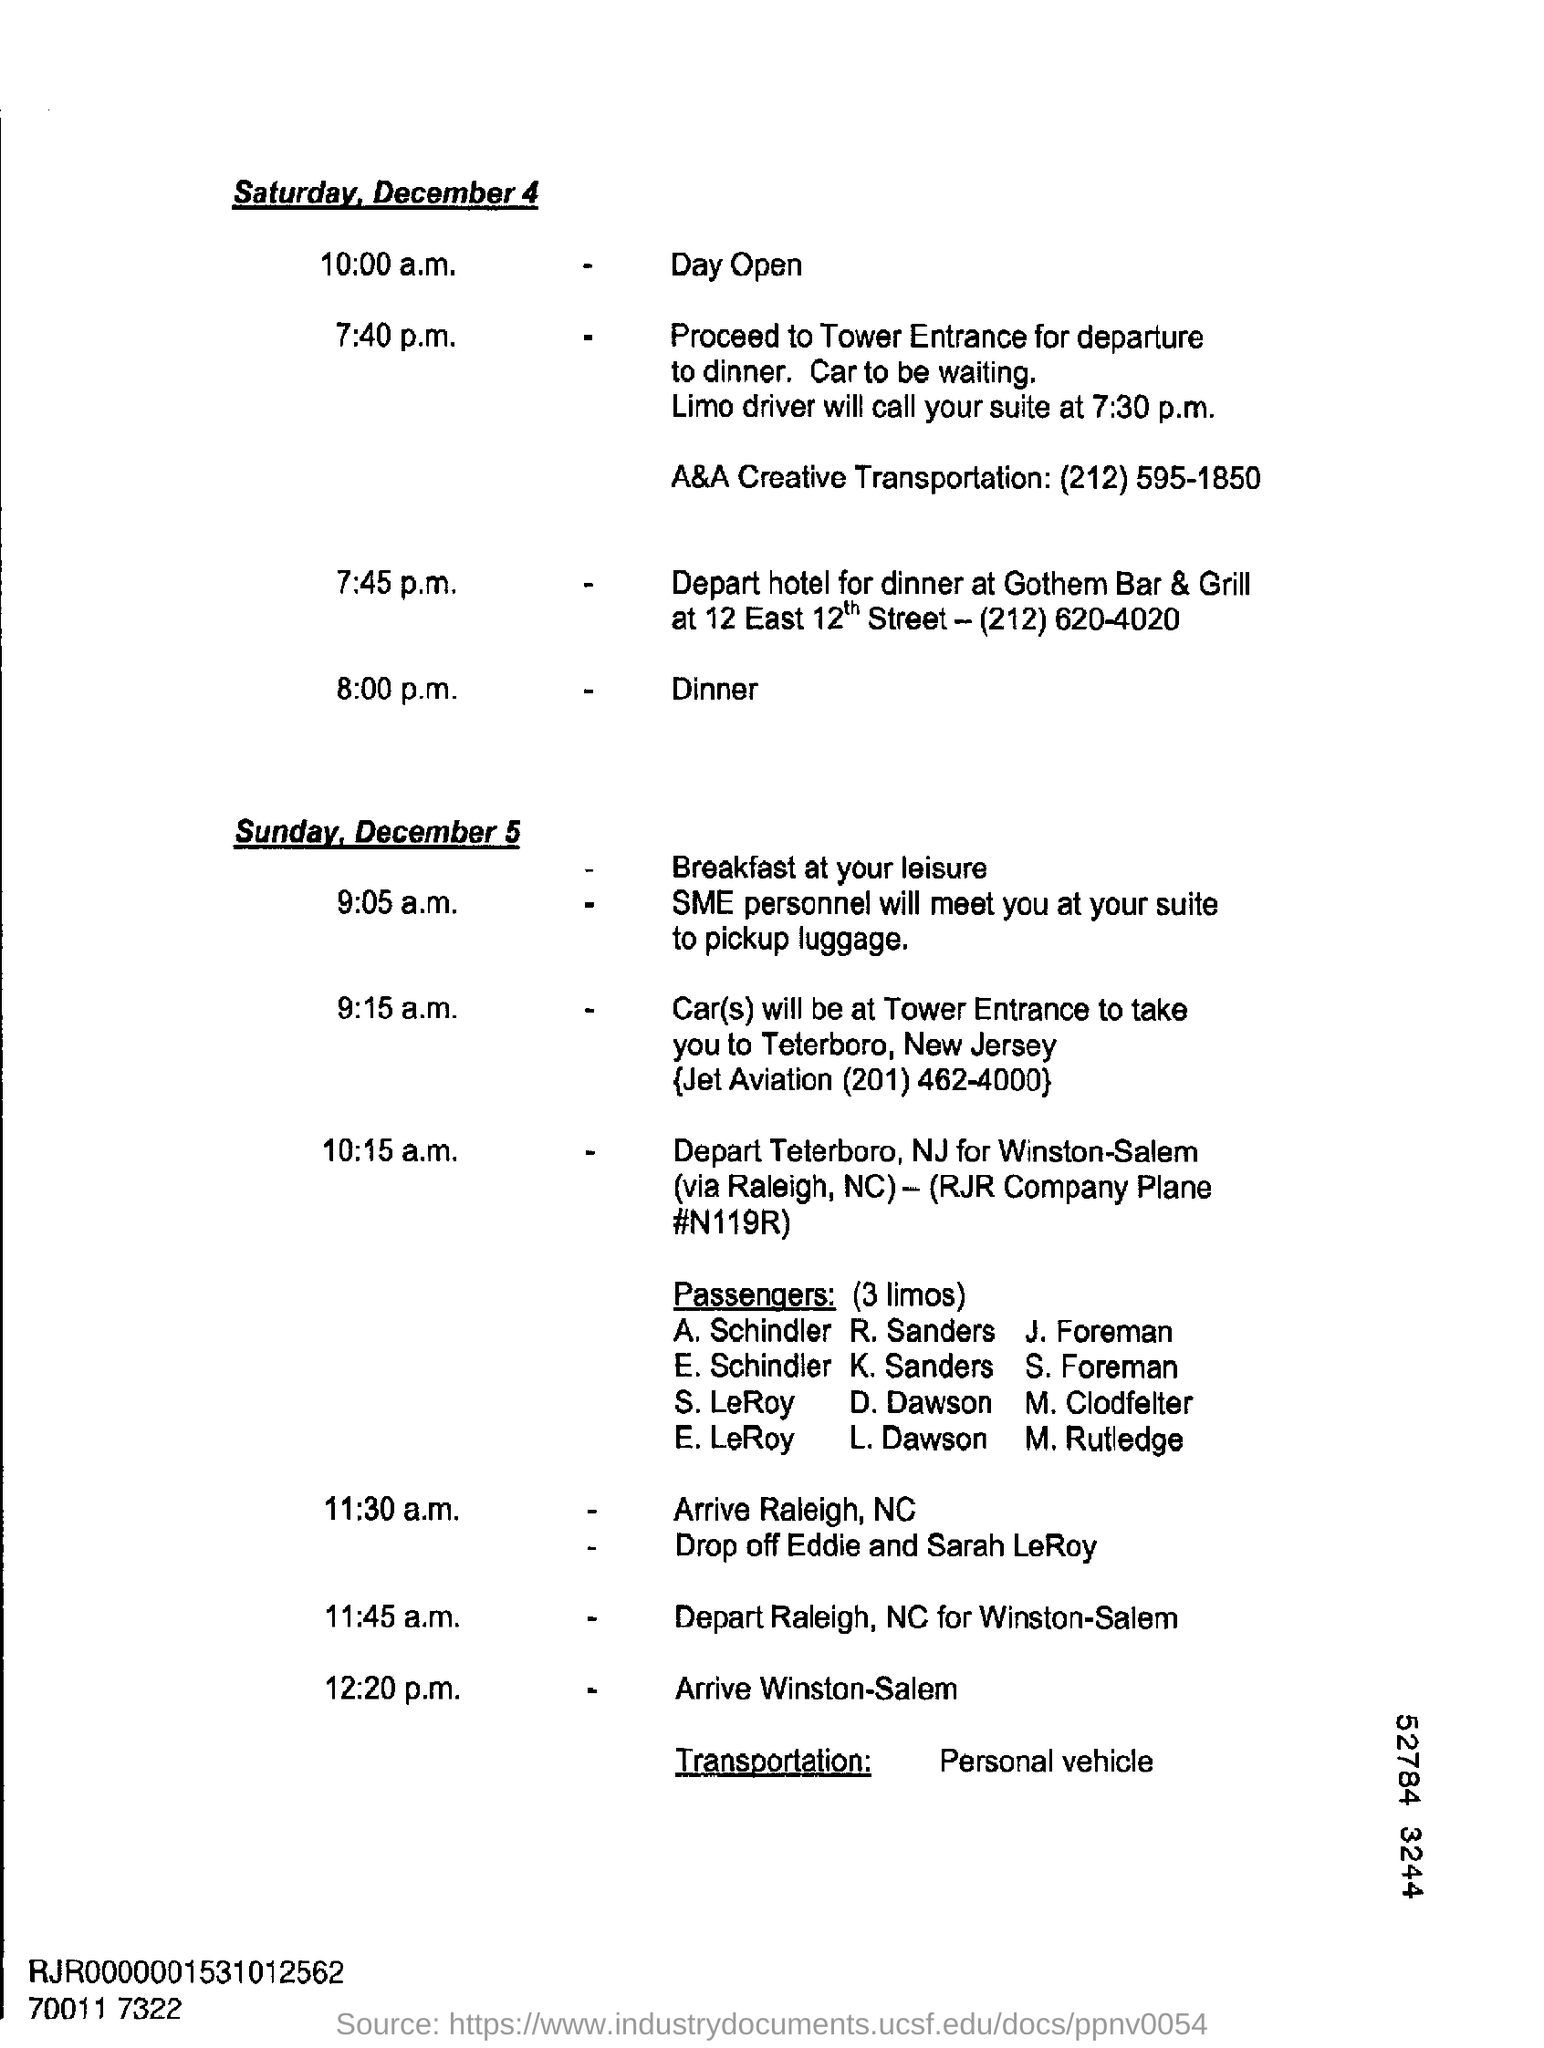What is the time mention in the document for open day?
Your answer should be very brief. 10:00 a.m. 